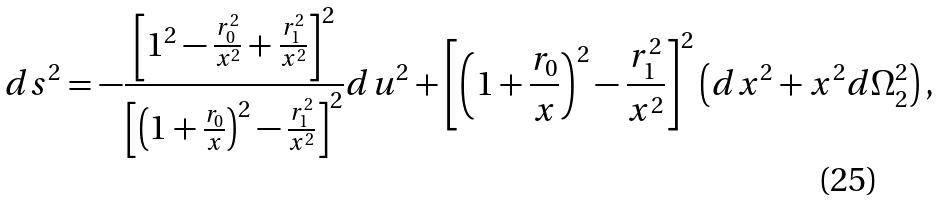Convert formula to latex. <formula><loc_0><loc_0><loc_500><loc_500>d s ^ { 2 } = - \frac { \left [ 1 ^ { 2 } - \frac { r _ { 0 } ^ { 2 } } { x ^ { 2 } } + \frac { r _ { 1 } ^ { 2 } } { x ^ { 2 } } \right ] ^ { 2 } } { \left [ \left ( 1 + \frac { r _ { 0 } } { x } \right ) ^ { 2 } - \frac { r _ { 1 } ^ { 2 } } { x ^ { 2 } } \right ] ^ { 2 } } d u ^ { 2 } + \left [ \left ( 1 + \frac { r _ { 0 } } { x } \right ) ^ { 2 } - \frac { r _ { 1 } ^ { 2 } } { x ^ { 2 } } \right ] ^ { 2 } \left ( d x ^ { 2 } + x ^ { 2 } d \Omega _ { 2 } ^ { 2 } \right ) ,</formula> 